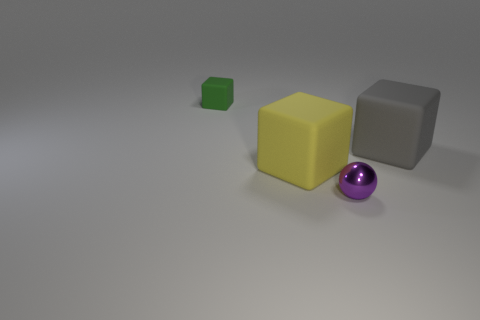Add 2 purple shiny things. How many objects exist? 6 Subtract all cubes. How many objects are left? 1 Subtract 1 purple spheres. How many objects are left? 3 Subtract all small green things. Subtract all shiny spheres. How many objects are left? 2 Add 3 large rubber objects. How many large rubber objects are left? 5 Add 1 tiny green matte objects. How many tiny green matte objects exist? 2 